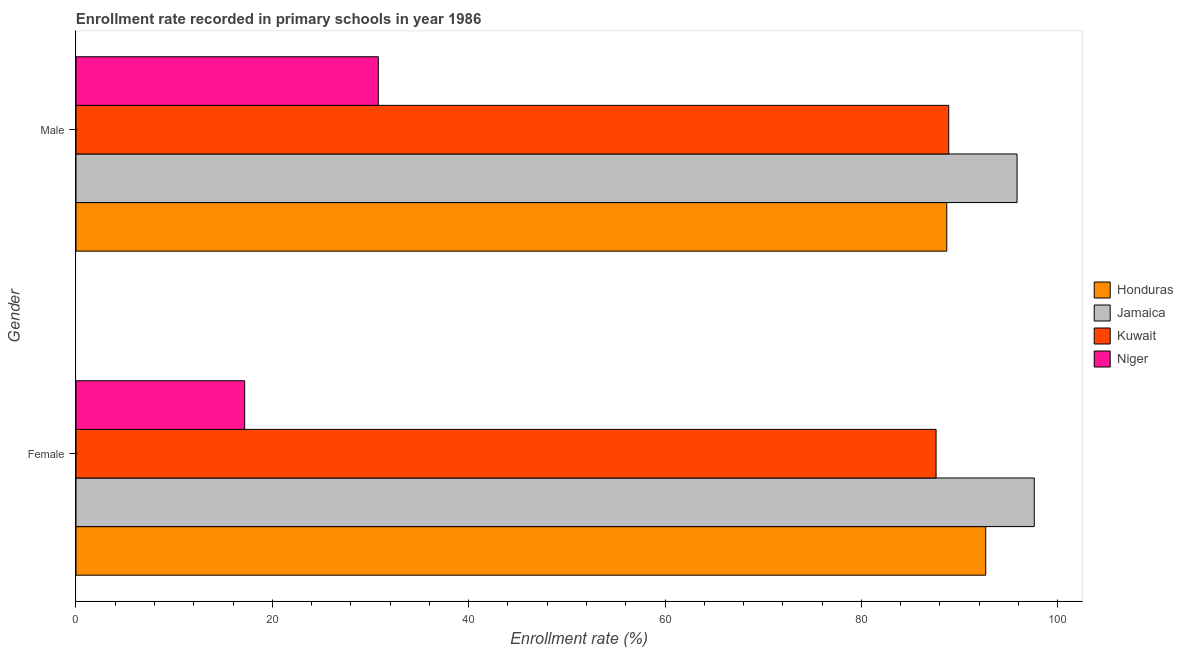How many bars are there on the 1st tick from the top?
Ensure brevity in your answer.  4. What is the enrollment rate of male students in Honduras?
Your response must be concise. 88.7. Across all countries, what is the maximum enrollment rate of male students?
Give a very brief answer. 95.86. Across all countries, what is the minimum enrollment rate of male students?
Keep it short and to the point. 30.8. In which country was the enrollment rate of female students maximum?
Offer a very short reply. Jamaica. In which country was the enrollment rate of male students minimum?
Your answer should be very brief. Niger. What is the total enrollment rate of female students in the graph?
Make the answer very short. 295.09. What is the difference between the enrollment rate of female students in Honduras and that in Niger?
Provide a short and direct response. 75.49. What is the difference between the enrollment rate of male students in Jamaica and the enrollment rate of female students in Honduras?
Your response must be concise. 3.19. What is the average enrollment rate of male students per country?
Offer a very short reply. 76.07. What is the difference between the enrollment rate of female students and enrollment rate of male students in Jamaica?
Give a very brief answer. 1.75. What is the ratio of the enrollment rate of male students in Niger to that in Kuwait?
Your answer should be compact. 0.35. What does the 2nd bar from the top in Female represents?
Offer a very short reply. Kuwait. What does the 3rd bar from the bottom in Female represents?
Give a very brief answer. Kuwait. Are all the bars in the graph horizontal?
Keep it short and to the point. Yes. What is the difference between two consecutive major ticks on the X-axis?
Make the answer very short. 20. Does the graph contain grids?
Ensure brevity in your answer.  No. How many legend labels are there?
Provide a succinct answer. 4. What is the title of the graph?
Your answer should be compact. Enrollment rate recorded in primary schools in year 1986. Does "Chad" appear as one of the legend labels in the graph?
Offer a very short reply. No. What is the label or title of the X-axis?
Ensure brevity in your answer.  Enrollment rate (%). What is the label or title of the Y-axis?
Make the answer very short. Gender. What is the Enrollment rate (%) in Honduras in Female?
Make the answer very short. 92.67. What is the Enrollment rate (%) in Jamaica in Female?
Offer a very short reply. 97.62. What is the Enrollment rate (%) of Kuwait in Female?
Provide a short and direct response. 87.61. What is the Enrollment rate (%) of Niger in Female?
Offer a terse response. 17.18. What is the Enrollment rate (%) of Honduras in Male?
Ensure brevity in your answer.  88.7. What is the Enrollment rate (%) in Jamaica in Male?
Your answer should be very brief. 95.86. What is the Enrollment rate (%) of Kuwait in Male?
Ensure brevity in your answer.  88.9. What is the Enrollment rate (%) of Niger in Male?
Your answer should be very brief. 30.8. Across all Gender, what is the maximum Enrollment rate (%) in Honduras?
Give a very brief answer. 92.67. Across all Gender, what is the maximum Enrollment rate (%) of Jamaica?
Provide a short and direct response. 97.62. Across all Gender, what is the maximum Enrollment rate (%) of Kuwait?
Your answer should be compact. 88.9. Across all Gender, what is the maximum Enrollment rate (%) of Niger?
Offer a terse response. 30.8. Across all Gender, what is the minimum Enrollment rate (%) in Honduras?
Your answer should be compact. 88.7. Across all Gender, what is the minimum Enrollment rate (%) of Jamaica?
Offer a terse response. 95.86. Across all Gender, what is the minimum Enrollment rate (%) in Kuwait?
Offer a very short reply. 87.61. Across all Gender, what is the minimum Enrollment rate (%) of Niger?
Provide a short and direct response. 17.18. What is the total Enrollment rate (%) in Honduras in the graph?
Keep it short and to the point. 181.37. What is the total Enrollment rate (%) of Jamaica in the graph?
Give a very brief answer. 193.48. What is the total Enrollment rate (%) in Kuwait in the graph?
Provide a short and direct response. 176.52. What is the total Enrollment rate (%) in Niger in the graph?
Provide a short and direct response. 47.98. What is the difference between the Enrollment rate (%) in Honduras in Female and that in Male?
Ensure brevity in your answer.  3.97. What is the difference between the Enrollment rate (%) in Jamaica in Female and that in Male?
Provide a short and direct response. 1.75. What is the difference between the Enrollment rate (%) in Kuwait in Female and that in Male?
Your answer should be compact. -1.29. What is the difference between the Enrollment rate (%) of Niger in Female and that in Male?
Your answer should be compact. -13.61. What is the difference between the Enrollment rate (%) in Honduras in Female and the Enrollment rate (%) in Jamaica in Male?
Your response must be concise. -3.19. What is the difference between the Enrollment rate (%) of Honduras in Female and the Enrollment rate (%) of Kuwait in Male?
Offer a terse response. 3.77. What is the difference between the Enrollment rate (%) in Honduras in Female and the Enrollment rate (%) in Niger in Male?
Provide a short and direct response. 61.88. What is the difference between the Enrollment rate (%) of Jamaica in Female and the Enrollment rate (%) of Kuwait in Male?
Your response must be concise. 8.71. What is the difference between the Enrollment rate (%) of Jamaica in Female and the Enrollment rate (%) of Niger in Male?
Ensure brevity in your answer.  66.82. What is the difference between the Enrollment rate (%) in Kuwait in Female and the Enrollment rate (%) in Niger in Male?
Your answer should be very brief. 56.82. What is the average Enrollment rate (%) of Honduras per Gender?
Provide a short and direct response. 90.69. What is the average Enrollment rate (%) in Jamaica per Gender?
Keep it short and to the point. 96.74. What is the average Enrollment rate (%) of Kuwait per Gender?
Provide a short and direct response. 88.26. What is the average Enrollment rate (%) of Niger per Gender?
Ensure brevity in your answer.  23.99. What is the difference between the Enrollment rate (%) in Honduras and Enrollment rate (%) in Jamaica in Female?
Provide a succinct answer. -4.95. What is the difference between the Enrollment rate (%) in Honduras and Enrollment rate (%) in Kuwait in Female?
Keep it short and to the point. 5.06. What is the difference between the Enrollment rate (%) in Honduras and Enrollment rate (%) in Niger in Female?
Provide a short and direct response. 75.49. What is the difference between the Enrollment rate (%) in Jamaica and Enrollment rate (%) in Kuwait in Female?
Keep it short and to the point. 10. What is the difference between the Enrollment rate (%) in Jamaica and Enrollment rate (%) in Niger in Female?
Your answer should be compact. 80.43. What is the difference between the Enrollment rate (%) in Kuwait and Enrollment rate (%) in Niger in Female?
Your answer should be compact. 70.43. What is the difference between the Enrollment rate (%) of Honduras and Enrollment rate (%) of Jamaica in Male?
Ensure brevity in your answer.  -7.16. What is the difference between the Enrollment rate (%) of Honduras and Enrollment rate (%) of Kuwait in Male?
Keep it short and to the point. -0.2. What is the difference between the Enrollment rate (%) of Honduras and Enrollment rate (%) of Niger in Male?
Offer a terse response. 57.91. What is the difference between the Enrollment rate (%) of Jamaica and Enrollment rate (%) of Kuwait in Male?
Ensure brevity in your answer.  6.96. What is the difference between the Enrollment rate (%) in Jamaica and Enrollment rate (%) in Niger in Male?
Make the answer very short. 65.07. What is the difference between the Enrollment rate (%) of Kuwait and Enrollment rate (%) of Niger in Male?
Provide a short and direct response. 58.11. What is the ratio of the Enrollment rate (%) of Honduras in Female to that in Male?
Provide a succinct answer. 1.04. What is the ratio of the Enrollment rate (%) of Jamaica in Female to that in Male?
Your answer should be compact. 1.02. What is the ratio of the Enrollment rate (%) of Kuwait in Female to that in Male?
Make the answer very short. 0.99. What is the ratio of the Enrollment rate (%) of Niger in Female to that in Male?
Your response must be concise. 0.56. What is the difference between the highest and the second highest Enrollment rate (%) in Honduras?
Offer a terse response. 3.97. What is the difference between the highest and the second highest Enrollment rate (%) in Jamaica?
Ensure brevity in your answer.  1.75. What is the difference between the highest and the second highest Enrollment rate (%) in Kuwait?
Provide a succinct answer. 1.29. What is the difference between the highest and the second highest Enrollment rate (%) of Niger?
Provide a short and direct response. 13.61. What is the difference between the highest and the lowest Enrollment rate (%) of Honduras?
Offer a very short reply. 3.97. What is the difference between the highest and the lowest Enrollment rate (%) in Jamaica?
Your answer should be very brief. 1.75. What is the difference between the highest and the lowest Enrollment rate (%) of Kuwait?
Provide a short and direct response. 1.29. What is the difference between the highest and the lowest Enrollment rate (%) in Niger?
Provide a succinct answer. 13.61. 